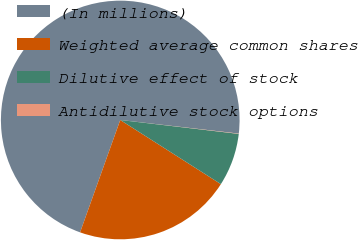Convert chart to OTSL. <chart><loc_0><loc_0><loc_500><loc_500><pie_chart><fcel>(In millions)<fcel>Weighted average common shares<fcel>Dilutive effect of stock<fcel>Antidilutive stock options<nl><fcel>71.35%<fcel>21.43%<fcel>7.17%<fcel>0.04%<nl></chart> 